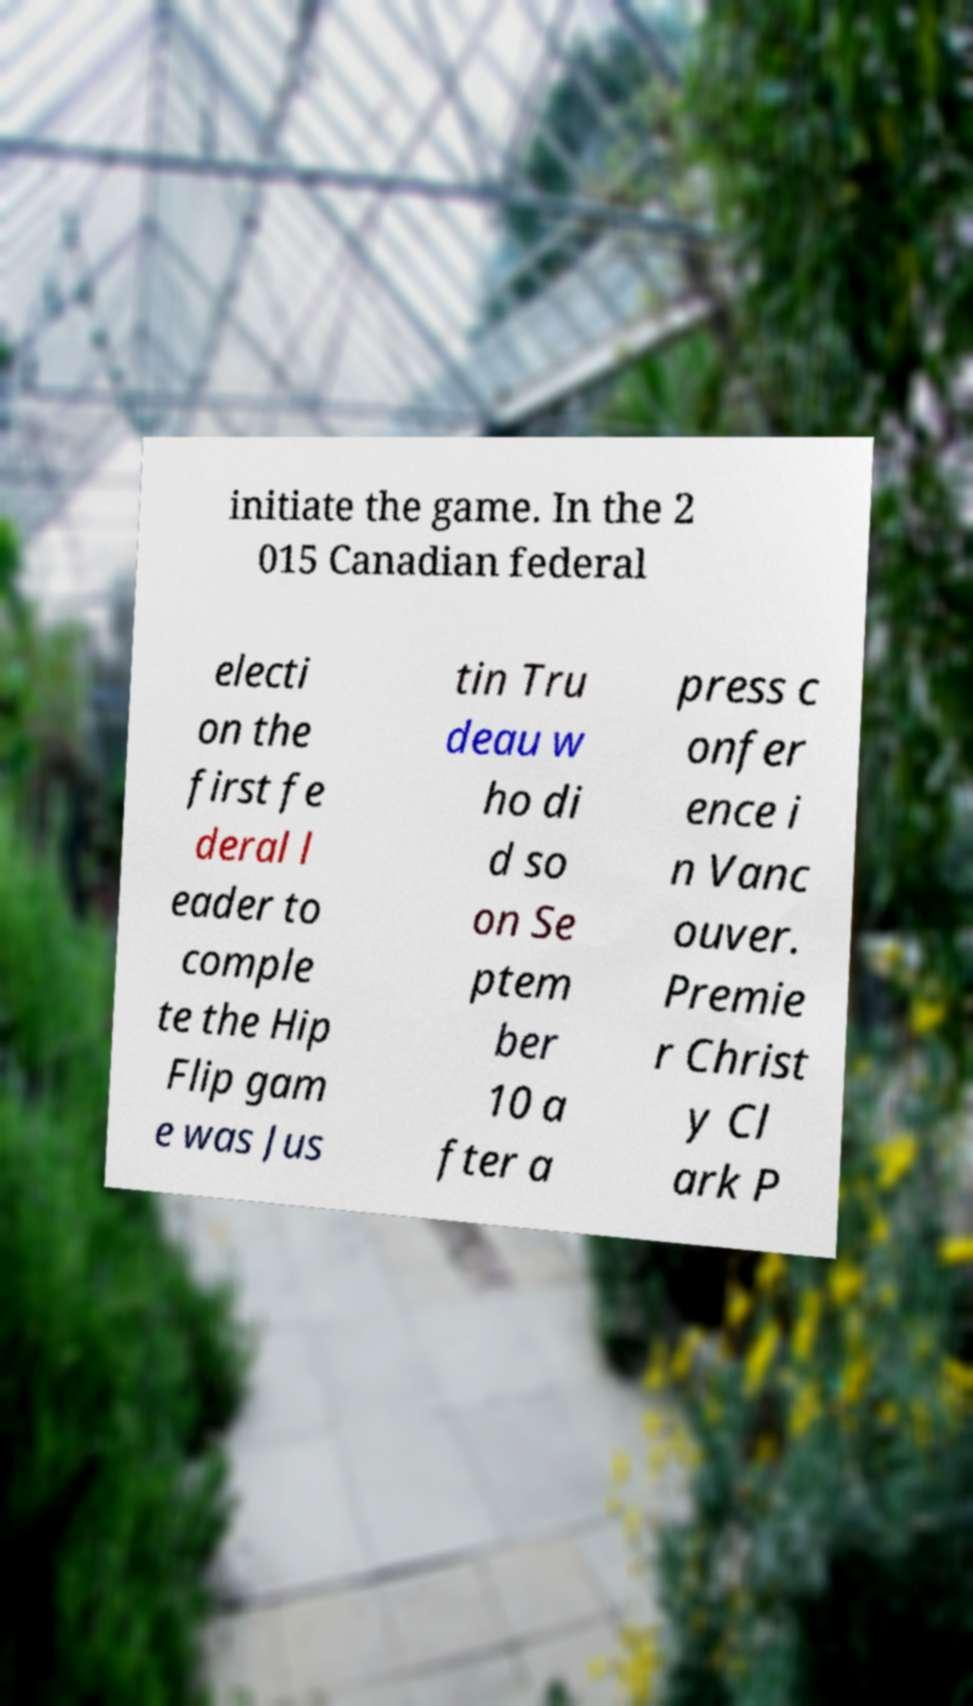Can you accurately transcribe the text from the provided image for me? initiate the game. In the 2 015 Canadian federal electi on the first fe deral l eader to comple te the Hip Flip gam e was Jus tin Tru deau w ho di d so on Se ptem ber 10 a fter a press c onfer ence i n Vanc ouver. Premie r Christ y Cl ark P 